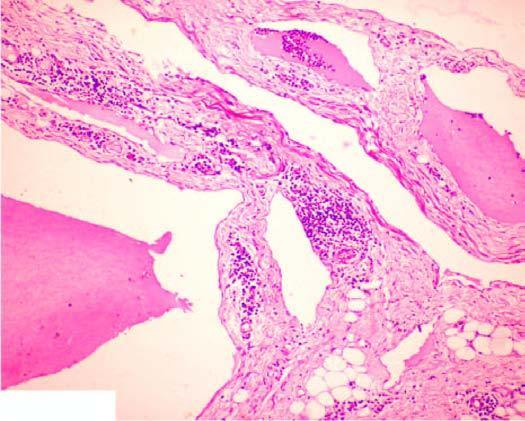does stroma show scattered collection of lymphocytes?
Answer the question using a single word or phrase. Yes 